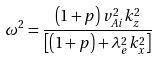<formula> <loc_0><loc_0><loc_500><loc_500>\omega ^ { 2 } = \frac { \left ( 1 + p \right ) v _ { A i } ^ { 2 } k _ { z } ^ { 2 } } { \left [ \left ( 1 + p \right ) + \lambda _ { e } ^ { 2 } k _ { x } ^ { 2 } \right ] }</formula> 